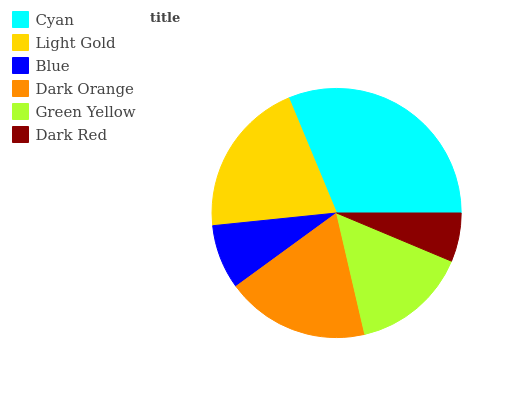Is Dark Red the minimum?
Answer yes or no. Yes. Is Cyan the maximum?
Answer yes or no. Yes. Is Light Gold the minimum?
Answer yes or no. No. Is Light Gold the maximum?
Answer yes or no. No. Is Cyan greater than Light Gold?
Answer yes or no. Yes. Is Light Gold less than Cyan?
Answer yes or no. Yes. Is Light Gold greater than Cyan?
Answer yes or no. No. Is Cyan less than Light Gold?
Answer yes or no. No. Is Dark Orange the high median?
Answer yes or no. Yes. Is Green Yellow the low median?
Answer yes or no. Yes. Is Green Yellow the high median?
Answer yes or no. No. Is Blue the low median?
Answer yes or no. No. 